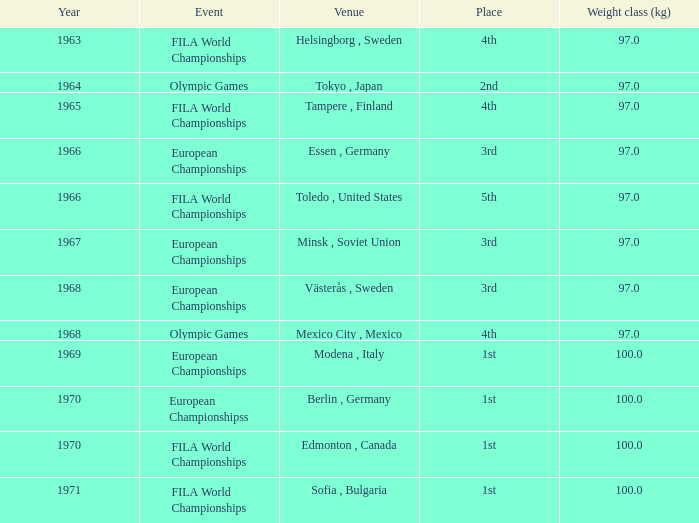What is the lowest weight class (kg) that has sofia, bulgaria as the venue? 100.0. 